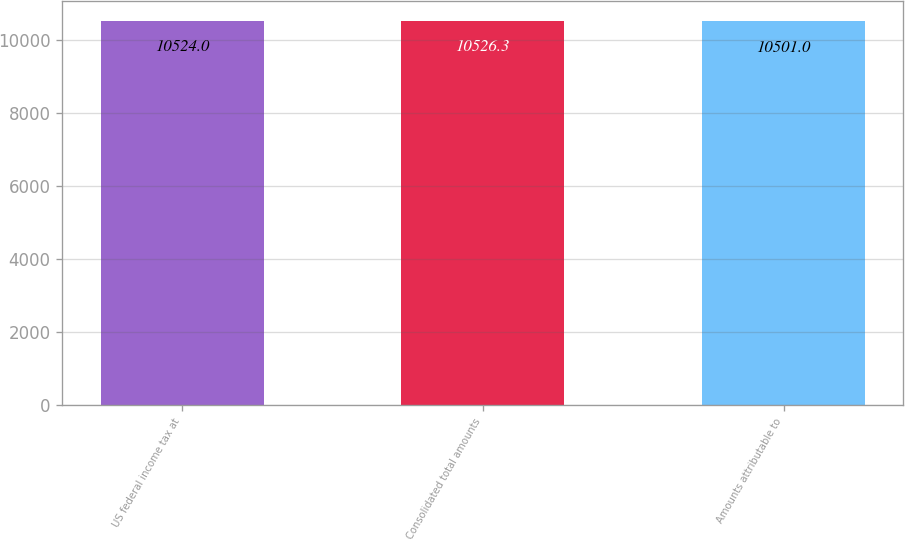Convert chart to OTSL. <chart><loc_0><loc_0><loc_500><loc_500><bar_chart><fcel>US federal income tax at<fcel>Consolidated total amounts<fcel>Amounts attributable to<nl><fcel>10524<fcel>10526.3<fcel>10501<nl></chart> 